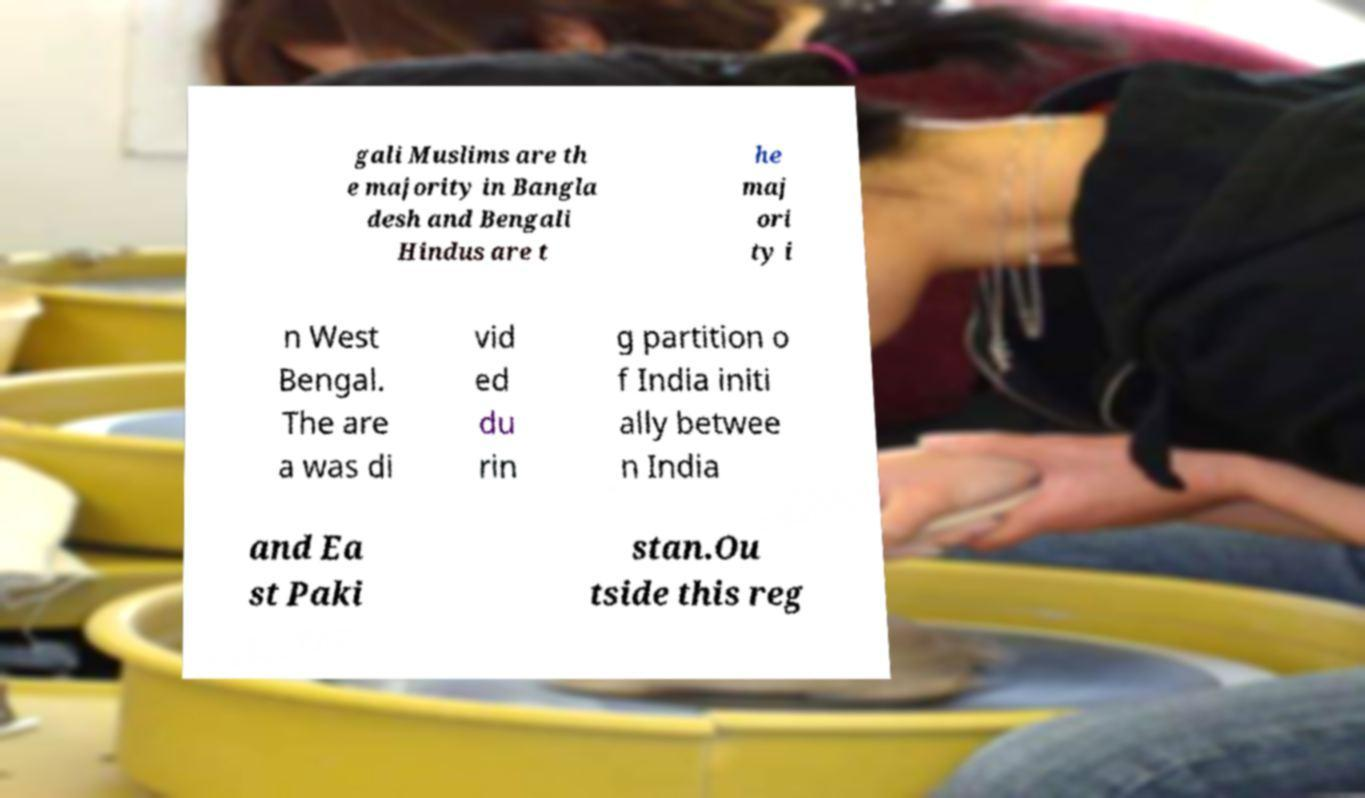There's text embedded in this image that I need extracted. Can you transcribe it verbatim? gali Muslims are th e majority in Bangla desh and Bengali Hindus are t he maj ori ty i n West Bengal. The are a was di vid ed du rin g partition o f India initi ally betwee n India and Ea st Paki stan.Ou tside this reg 